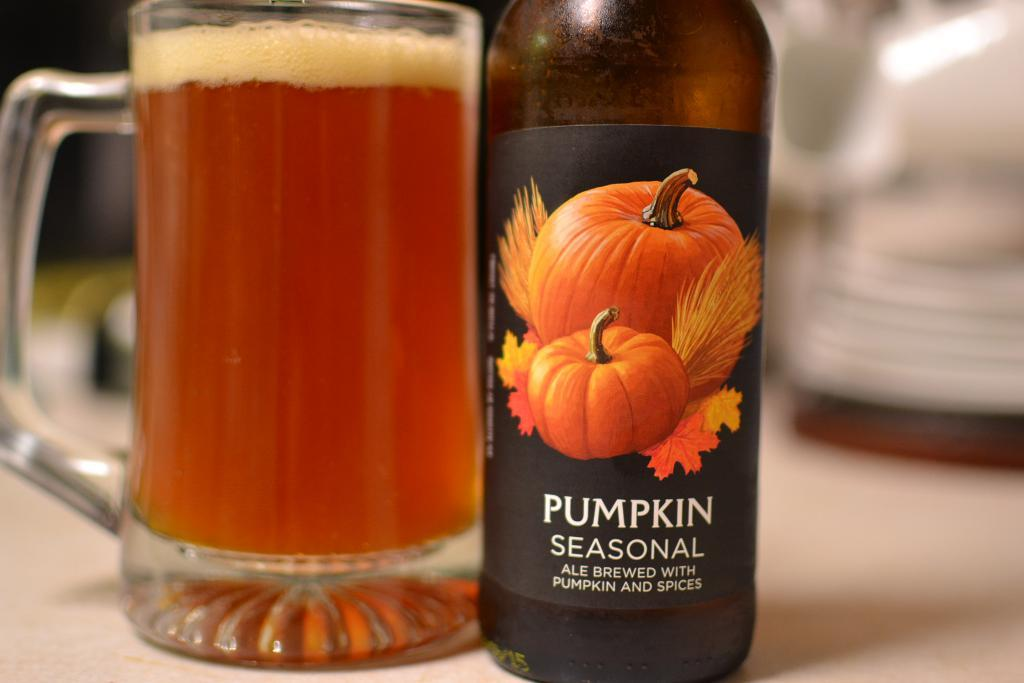What is depicted on the label of the bottle in the image? The label has pumpkins and leaves depicted on it. What is the bottle containing? The bottle has a label of pumpkins and leaves, but the contents are not specified in the facts. What is in the glass in the image? There is a glass with liquid in it in the image. Where is the glass placed? The glass is on a wooden board. How would you describe the background of the image? The background of the image is blurred. What type of drain is visible in the image? There is no drain present in the image. How deep is the hole in the wooden board? There is no hole present in the wooden board or the image. 